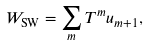Convert formula to latex. <formula><loc_0><loc_0><loc_500><loc_500>W _ { \text {SW} } = \sum _ { m } T ^ { m } u _ { m + 1 } ,</formula> 